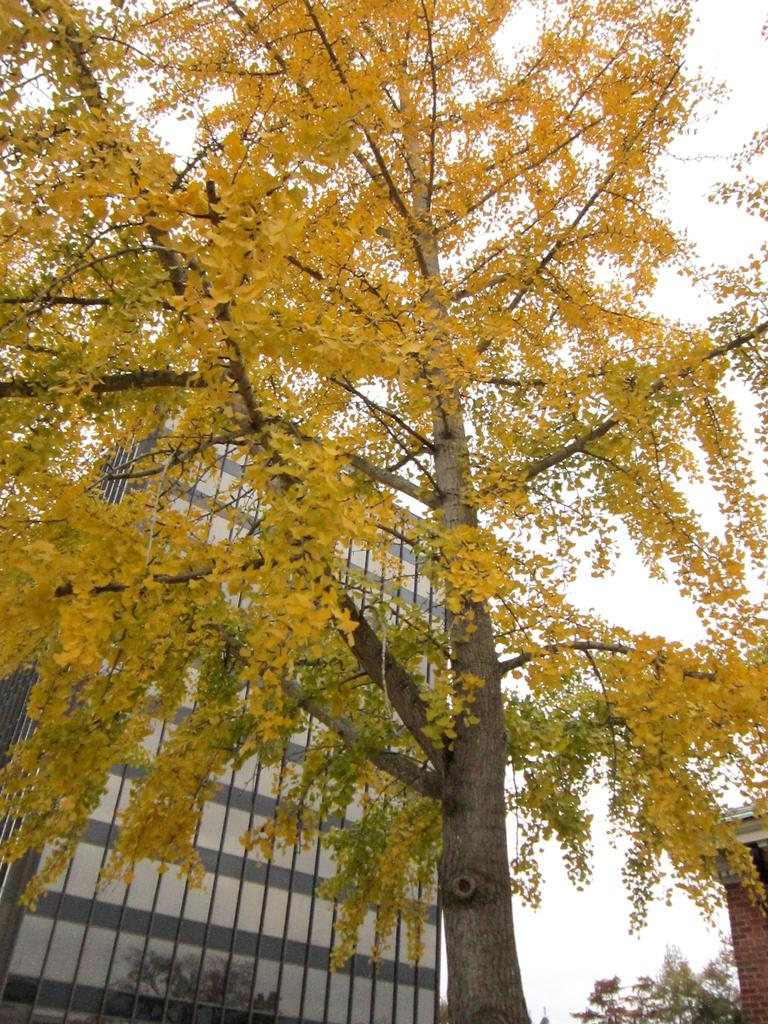What type of plant can be seen in the image? There is a tree in the image. What type of structure is visible in the background of the image? There is a building in the background of the image. Can you describe another plant visible in the background of the image? There is another tree in the background of the image. What is visible in the background of the image besides the building and trees? The sky is visible in the background of the image. What type of question can be seen written on the sheet in the image? There is no sheet or question present in the image. How many snails can be seen crawling on the tree in the image? There are no snails visible on the tree in the image. 